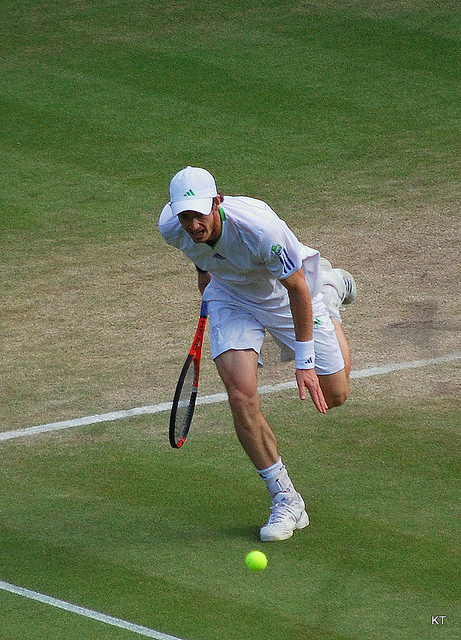Identify the text displayed in this image. KT 